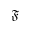<formula> <loc_0><loc_0><loc_500><loc_500>\mathfrak { F }</formula> 